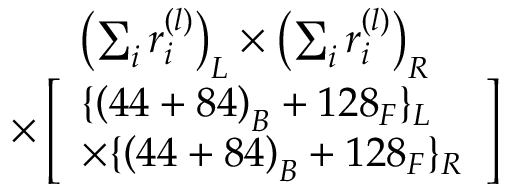Convert formula to latex. <formula><loc_0><loc_0><loc_500><loc_500>\begin{array} { c } { { \left ( \sum _ { i } r _ { i } ^ { ( l ) } \right ) _ { L } \times \left ( \sum _ { i } r _ { i } ^ { ( l ) } \right ) _ { R } } } \\ { { \times \left [ \begin{array} { l } { { \{ \left ( 4 4 + 8 4 \right ) _ { B } + 1 2 8 _ { F } \} _ { L } } } \\ { { \times \{ \left ( 4 4 + 8 4 \right ) _ { B } + 1 2 8 _ { F } \} _ { R } } } \end{array} \right ] } } \end{array}</formula> 